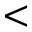Convert formula to latex. <formula><loc_0><loc_0><loc_500><loc_500><</formula> 